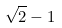Convert formula to latex. <formula><loc_0><loc_0><loc_500><loc_500>\sqrt { 2 } - 1</formula> 